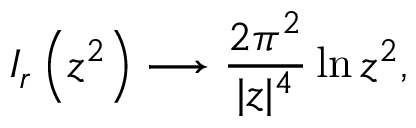<formula> <loc_0><loc_0><loc_500><loc_500>I _ { r } \left ( z ^ { 2 } \right ) \longrightarrow \frac { 2 \pi ^ { 2 } } { | z | ^ { 4 } } \ln z ^ { 2 } ,</formula> 